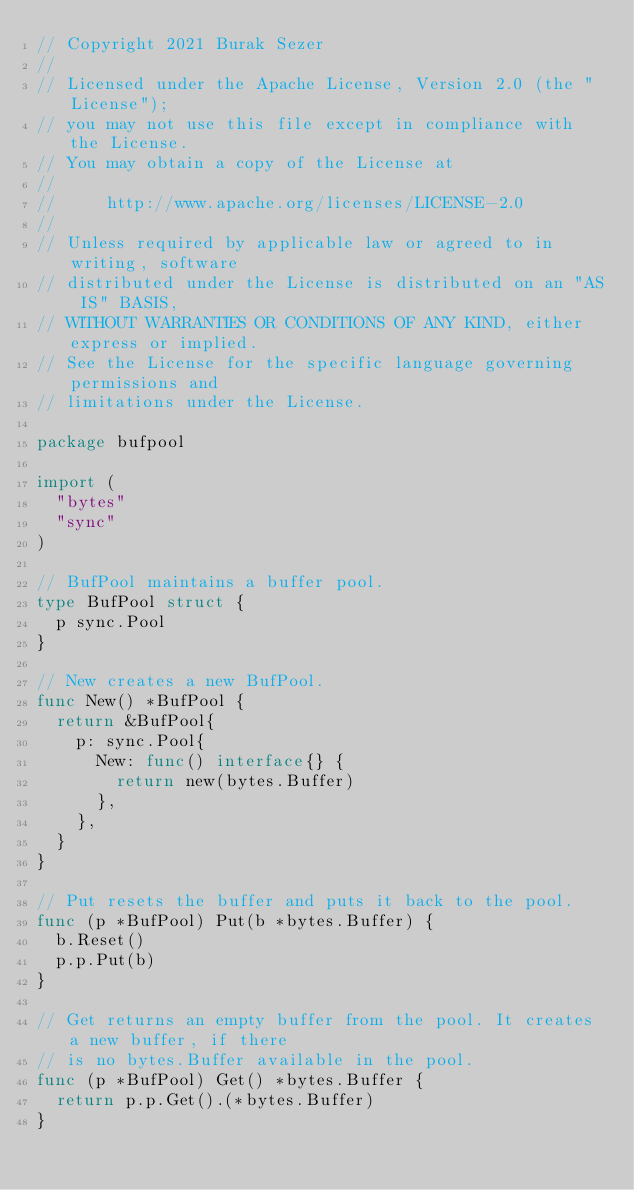Convert code to text. <code><loc_0><loc_0><loc_500><loc_500><_Go_>// Copyright 2021 Burak Sezer
//
// Licensed under the Apache License, Version 2.0 (the "License");
// you may not use this file except in compliance with the License.
// You may obtain a copy of the License at
//
//     http://www.apache.org/licenses/LICENSE-2.0
//
// Unless required by applicable law or agreed to in writing, software
// distributed under the License is distributed on an "AS IS" BASIS,
// WITHOUT WARRANTIES OR CONDITIONS OF ANY KIND, either express or implied.
// See the License for the specific language governing permissions and
// limitations under the License.

package bufpool

import (
	"bytes"
	"sync"
)

// BufPool maintains a buffer pool.
type BufPool struct {
	p sync.Pool
}

// New creates a new BufPool.
func New() *BufPool {
	return &BufPool{
		p: sync.Pool{
			New: func() interface{} {
				return new(bytes.Buffer)
			},
		},
	}
}

// Put resets the buffer and puts it back to the pool.
func (p *BufPool) Put(b *bytes.Buffer) {
	b.Reset()
	p.p.Put(b)
}

// Get returns an empty buffer from the pool. It creates a new buffer, if there
// is no bytes.Buffer available in the pool.
func (p *BufPool) Get() *bytes.Buffer {
	return p.p.Get().(*bytes.Buffer)
}
</code> 